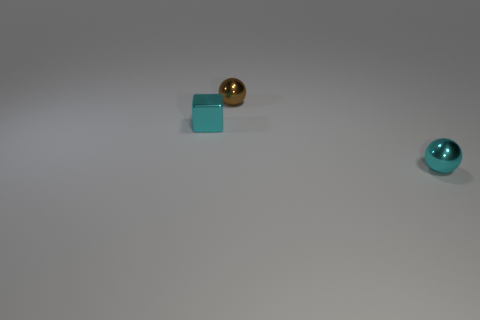Are there any large metallic cylinders of the same color as the tiny cube?
Your answer should be compact. No. There is another ball that is the same size as the brown sphere; what color is it?
Make the answer very short. Cyan. Is the color of the block the same as the tiny ball left of the small cyan ball?
Your answer should be very brief. No. What is the color of the small cube?
Your answer should be very brief. Cyan. What material is the cyan object in front of the tiny metallic cube?
Keep it short and to the point. Metal. What size is the cyan shiny thing that is the same shape as the tiny brown metallic object?
Provide a short and direct response. Small. Are there fewer cubes that are behind the cyan metallic block than small cyan objects?
Offer a very short reply. Yes. Is there a small shiny ball?
Offer a very short reply. Yes. There is another tiny metallic thing that is the same shape as the small brown shiny object; what is its color?
Make the answer very short. Cyan. There is a shiny ball that is in front of the tiny brown shiny sphere; is it the same color as the block?
Your answer should be compact. Yes. 